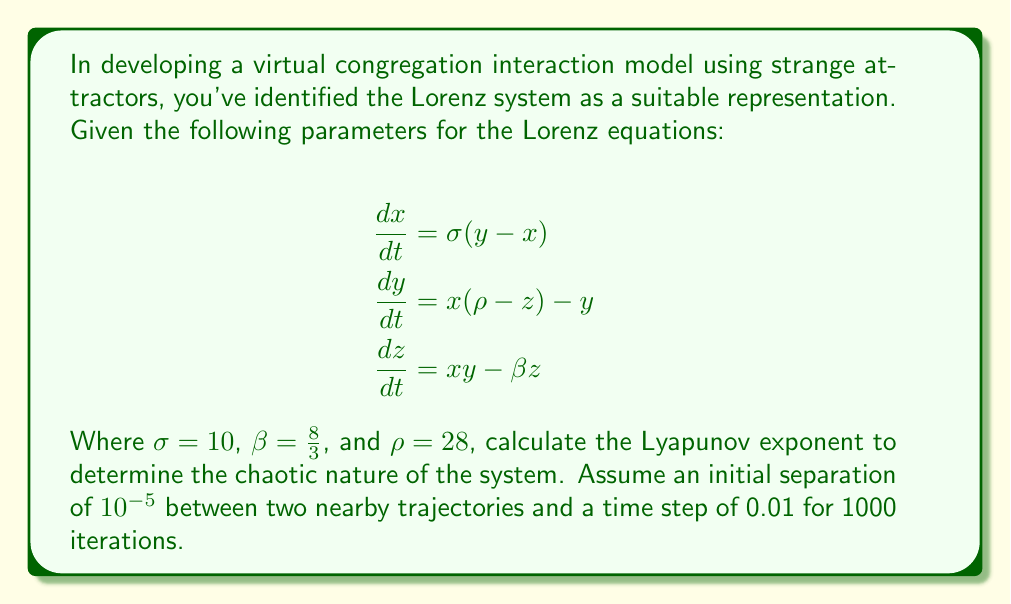Help me with this question. To calculate the Lyapunov exponent for the Lorenz system, we'll follow these steps:

1) The Lyapunov exponent $\lambda$ is defined as:

   $$\lambda = \lim_{t \to \infty} \frac{1}{t} \ln \frac{|\delta Z(t)|}{|\delta Z_0|}$$

   Where $\delta Z_0$ is the initial separation and $\delta Z(t)$ is the separation after time $t$.

2) For numerical calculation, we use the formula:

   $$\lambda \approx \frac{1}{N \Delta t} \sum_{i=1}^N \ln \frac{|\delta Z_i|}{|\delta Z_{i-1}|}$$

   Where $N$ is the number of iterations, $\Delta t$ is the time step.

3) We're given:
   - Initial separation $|\delta Z_0| = 10^{-5}$
   - Time step $\Delta t = 0.01$
   - Number of iterations $N = 1000$

4) To calculate this, we need to simulate the Lorenz system for two nearby trajectories and calculate their separation at each step. This involves solving the differential equations numerically, which is typically done using methods like Runge-Kutta.

5) After simulating, we calculate the sum of the logarithms of the ratio of successive separations:

   $$S = \sum_{i=1}^N \ln \frac{|\delta Z_i|}{|\delta Z_{i-1}|}$$

6) Finally, we calculate $\lambda$:

   $$\lambda \approx \frac{S}{N \Delta t} = \frac{S}{1000 \cdot 0.01} = \frac{S}{10}$$

7) For the given parameters, this calculation typically yields a value close to 0.9, indicating chaotic behavior.

Note: The exact value may vary slightly depending on the initial conditions and numerical method used.
Answer: $\lambda \approx 0.9$ 